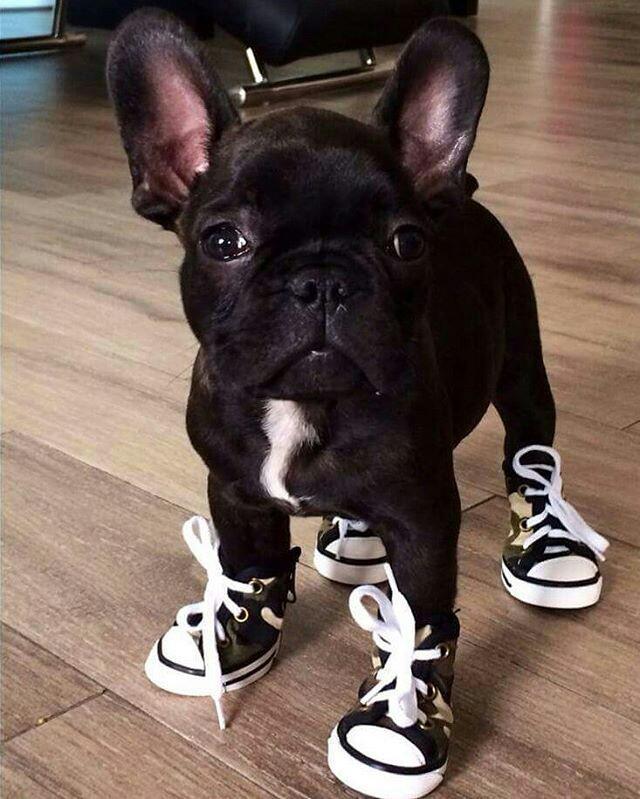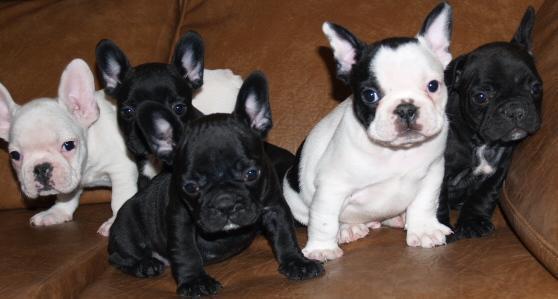The first image is the image on the left, the second image is the image on the right. For the images displayed, is the sentence "One image shows exactly two real puppies posed on a plush surface." factually correct? Answer yes or no. No. The first image is the image on the left, the second image is the image on the right. For the images shown, is this caption "There are exactly three dogs." true? Answer yes or no. No. The first image is the image on the left, the second image is the image on the right. Assess this claim about the two images: "A total of three puppies are shown, most of them sitting.". Correct or not? Answer yes or no. No. The first image is the image on the left, the second image is the image on the right. Analyze the images presented: Is the assertion "There are exactly three puppies." valid? Answer yes or no. No. 